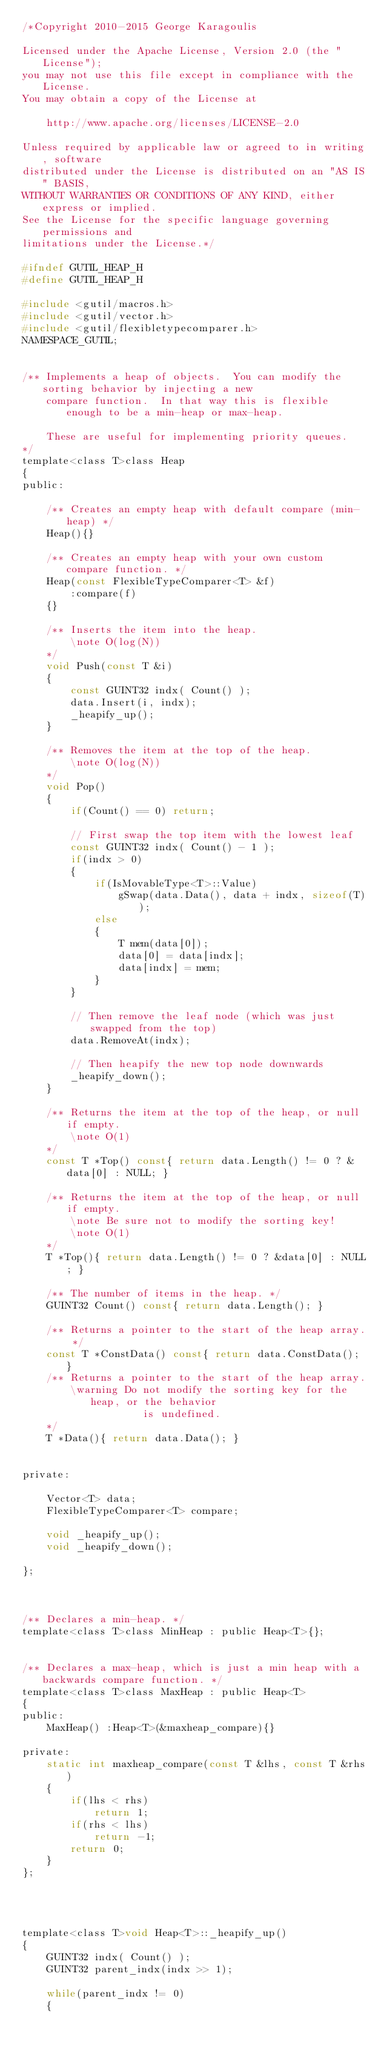<code> <loc_0><loc_0><loc_500><loc_500><_C_>/*Copyright 2010-2015 George Karagoulis

Licensed under the Apache License, Version 2.0 (the "License");
you may not use this file except in compliance with the License.
You may obtain a copy of the License at

    http://www.apache.org/licenses/LICENSE-2.0

Unless required by applicable law or agreed to in writing, software
distributed under the License is distributed on an "AS IS" BASIS,
WITHOUT WARRANTIES OR CONDITIONS OF ANY KIND, either express or implied.
See the License for the specific language governing permissions and
limitations under the License.*/

#ifndef GUTIL_HEAP_H
#define GUTIL_HEAP_H

#include <gutil/macros.h>
#include <gutil/vector.h>
#include <gutil/flexibletypecomparer.h>
NAMESPACE_GUTIL;


/** Implements a heap of objects.  You can modify the sorting behavior by injecting a new
    compare function.  In that way this is flexible enough to be a min-heap or max-heap.

    These are useful for implementing priority queues.
*/
template<class T>class Heap
{
public:

    /** Creates an empty heap with default compare (min-heap) */
    Heap(){}

    /** Creates an empty heap with your own custom compare function. */
    Heap(const FlexibleTypeComparer<T> &f)
        :compare(f)
    {}

    /** Inserts the item into the heap.
        \note O(log(N))
    */
    void Push(const T &i)
    {
        const GUINT32 indx( Count() );
        data.Insert(i, indx);
        _heapify_up();
    }

    /** Removes the item at the top of the heap.
        \note O(log(N))
    */
    void Pop()
    {
        if(Count() == 0) return;

        // First swap the top item with the lowest leaf
        const GUINT32 indx( Count() - 1 );
        if(indx > 0)
        {
            if(IsMovableType<T>::Value)
                gSwap(data.Data(), data + indx, sizeof(T));
            else
            {
                T mem(data[0]);
                data[0] = data[indx];
                data[indx] = mem;
            }
        }

        // Then remove the leaf node (which was just swapped from the top)
        data.RemoveAt(indx);

        // Then heapify the new top node downwards
        _heapify_down();
    }

    /** Returns the item at the top of the heap, or null if empty.
        \note O(1)
    */
    const T *Top() const{ return data.Length() != 0 ? &data[0] : NULL; }

    /** Returns the item at the top of the heap, or null if empty.
        \note Be sure not to modify the sorting key!
        \note O(1)
    */
    T *Top(){ return data.Length() != 0 ? &data[0] : NULL; }

    /** The number of items in the heap. */
    GUINT32 Count() const{ return data.Length(); }

    /** Returns a pointer to the start of the heap array. */
    const T *ConstData() const{ return data.ConstData(); }
    /** Returns a pointer to the start of the heap array.
        \warning Do not modify the sorting key for the heap, or the behavior
                    is undefined.
    */
    T *Data(){ return data.Data(); }


private:

    Vector<T> data;
    FlexibleTypeComparer<T> compare;

    void _heapify_up();
    void _heapify_down();

};



/** Declares a min-heap. */
template<class T>class MinHeap : public Heap<T>{};


/** Declares a max-heap, which is just a min heap with a backwards compare function. */
template<class T>class MaxHeap : public Heap<T>
{
public:
    MaxHeap() :Heap<T>(&maxheap_compare){}

private:
    static int maxheap_compare(const T &lhs, const T &rhs)
    {
        if(lhs < rhs)
            return 1;
        if(rhs < lhs)
            return -1;
        return 0;
    }
};




template<class T>void Heap<T>::_heapify_up()
{
    GUINT32 indx( Count() );
    GUINT32 parent_indx(indx >> 1);

    while(parent_indx != 0)
    {</code> 